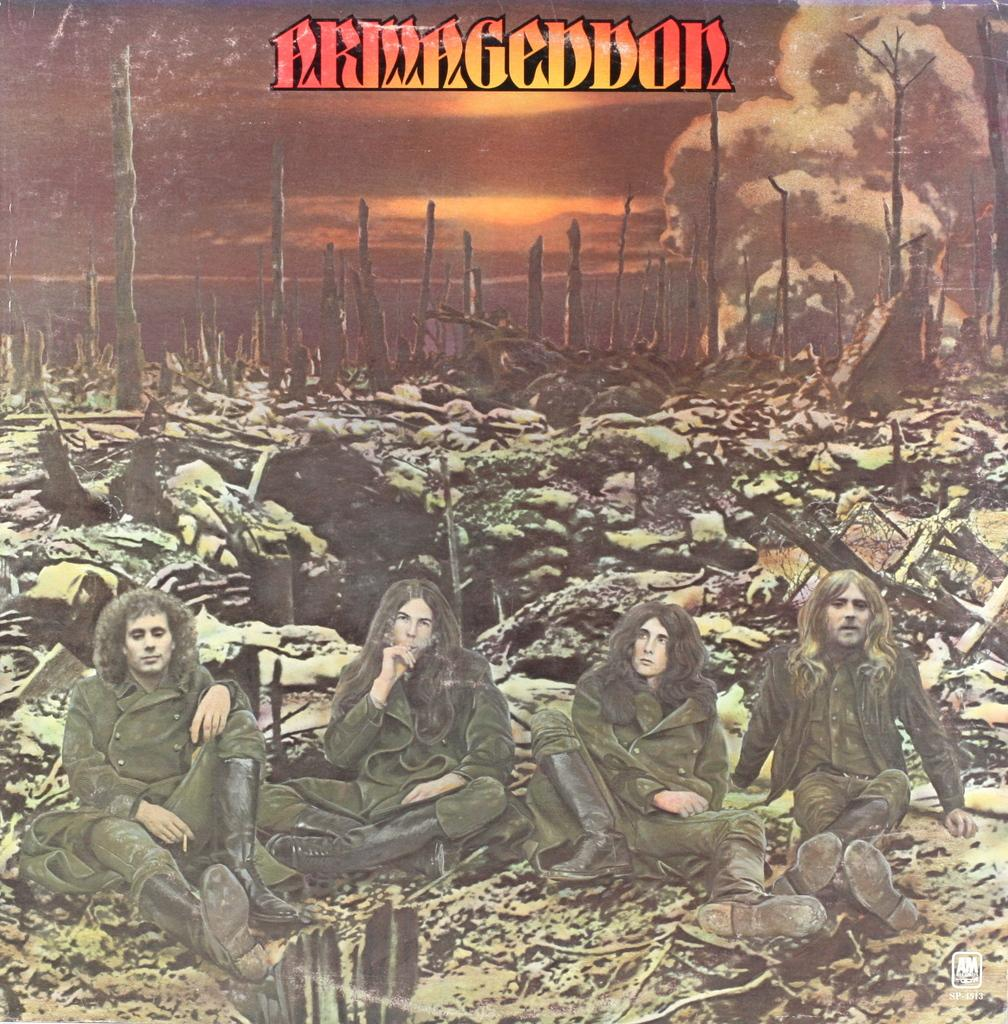What type of visual is the image? The image is a poster. What are the people in the poster doing? There is a group of people sitting on the ground in the poster. What can be seen in the background of the poster? There are wooden poles and some objects in the background of the poster. Is there any text on the poster? Yes, there is text on the poster. What color is the grape that the dad is holding in the image? There is no dad or grape present in the image. Is the wool used to make any of the objects in the background of the poster? There is no wool or any indication of its use in the image. 